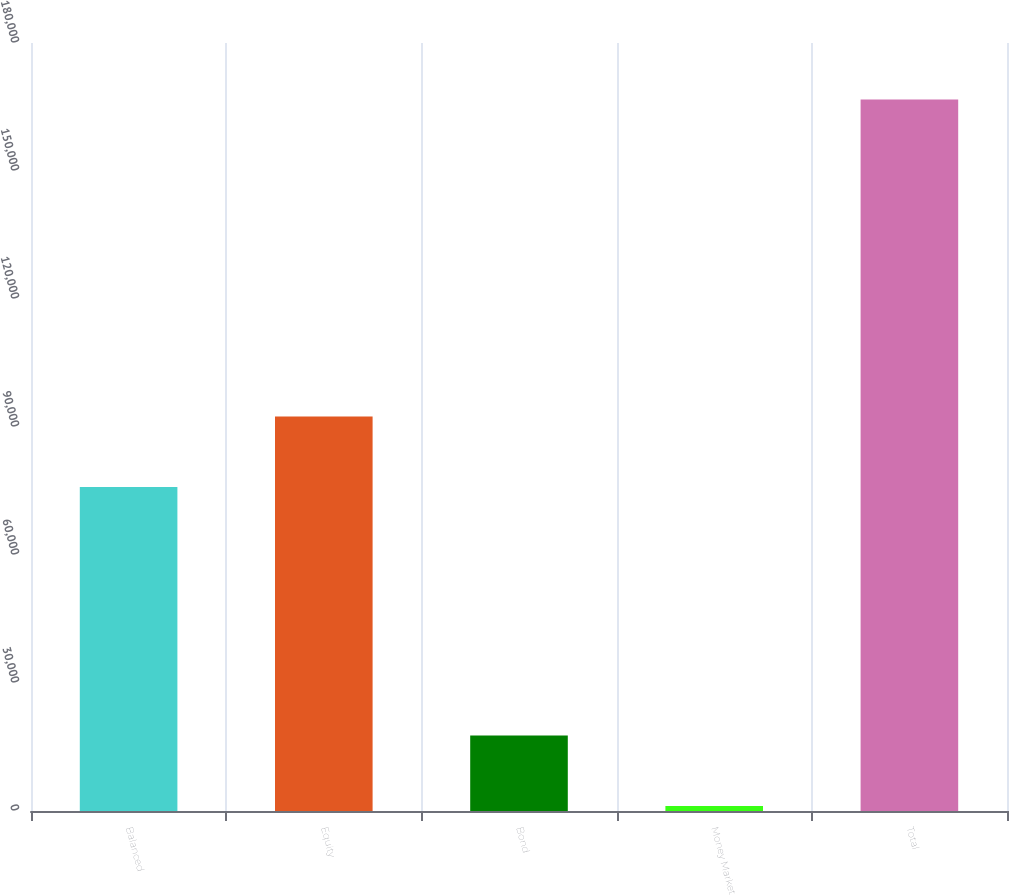Convert chart to OTSL. <chart><loc_0><loc_0><loc_500><loc_500><bar_chart><fcel>Balanced<fcel>Equity<fcel>Bond<fcel>Money Market<fcel>Total<nl><fcel>75928<fcel>92487.6<fcel>17716.6<fcel>1157<fcel>166753<nl></chart> 